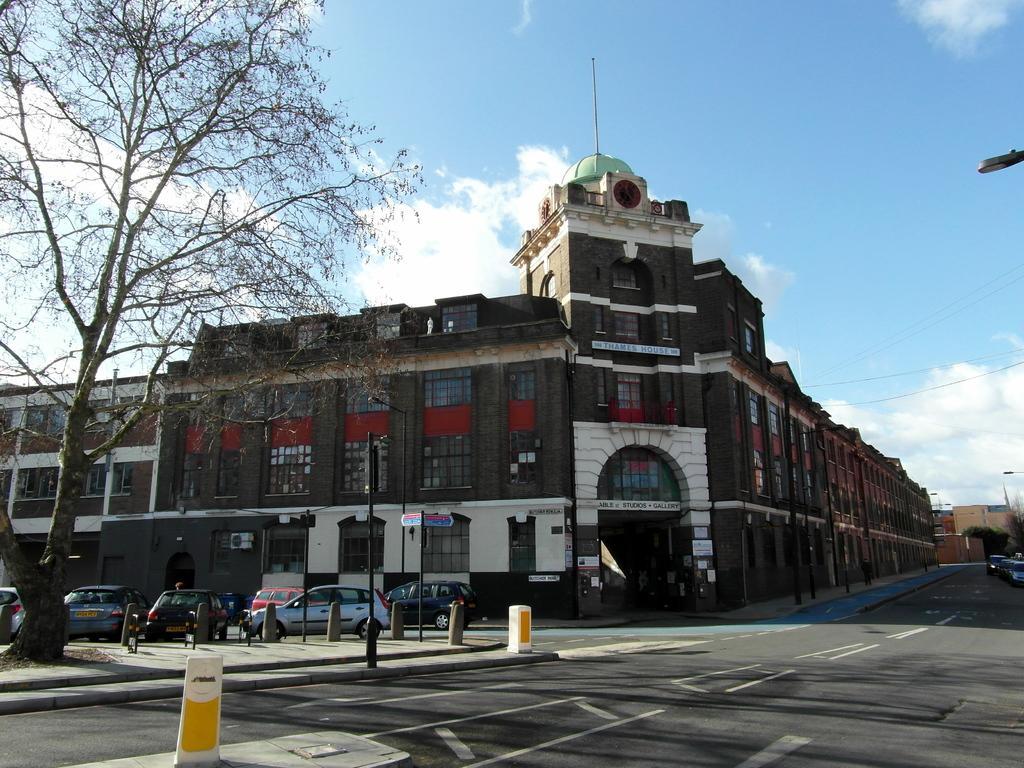Could you give a brief overview of what you see in this image? In this image we can one big building, some text is there on building and one small building. There are many trees, three street lights, one sign board, one flag, one board, two safety poles and some poles are there around the building. Many cars are parked near to the building. One road is there, one side of the road some cars are parked. 